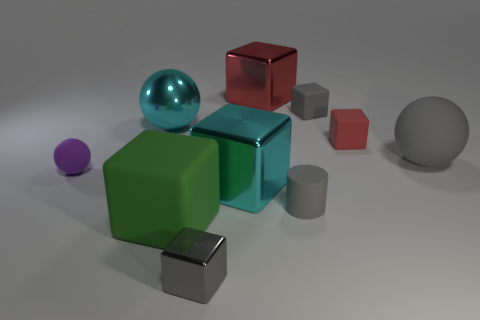Subtract all green blocks. How many blocks are left? 5 Subtract all cyan shiny blocks. How many blocks are left? 5 Subtract all spheres. How many objects are left? 7 Subtract 3 cubes. How many cubes are left? 3 Subtract all yellow blocks. How many gray spheres are left? 1 Subtract all blue blocks. Subtract all blue cylinders. How many blocks are left? 6 Subtract all large red metal things. Subtract all cyan balls. How many objects are left? 8 Add 5 tiny gray rubber blocks. How many tiny gray rubber blocks are left? 6 Add 8 large yellow metallic spheres. How many large yellow metallic spheres exist? 8 Subtract 0 purple blocks. How many objects are left? 10 